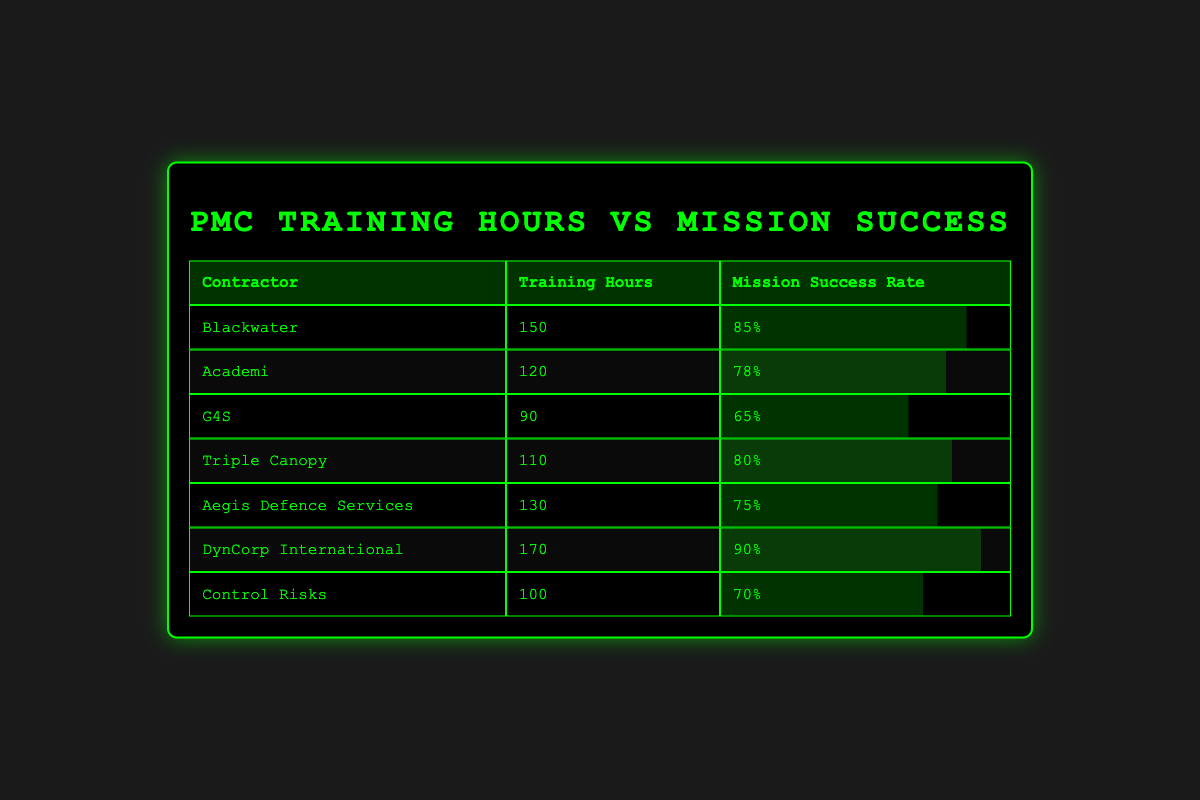What is the mission success rate for DynCorp International? From the table, I can see that the mission success rate for DynCorp International is listed in the corresponding row. It shows 90%.
Answer: 90% Which contractor has the highest number of training hours? By checking the "Training Hours" column, it is clear that DynCorp International has the highest training hours at 170.
Answer: DynCorp International What is the average mission success rate of all the contractors listed? To find the average, I add up all the mission success rates (0.85 + 0.78 + 0.65 + 0.80 + 0.75 + 0.90 + 0.70 = 5.63) and divide by the total number of contractors (7). So, 5.63 / 7 = 0.8042857, which rounds to 80.43%.
Answer: 80.43% Is the training hours for Aegis Defence Services greater than the training hours for G4S? The training hours for Aegis Defence Services is 130, while G4S has 90. Since 130 is greater than 90, the statement is true.
Answer: Yes What is the difference in mission success rate between Blackwater and Control Risks? Blackwater has a mission success rate of 0.85 and Control Risks has 0.70. To find the difference, I subtract: 0.85 - 0.70 = 0.15. Therefore, the difference is 0.15, or 15%.
Answer: 0.15 or 15% Which contractors have a mission success rate above 80%? By reviewing the "Mission Success Rate" column, I can identify that Blackwater (0.85), Triple Canopy (0.80), and DynCorp International (0.90) all have mission success rates above 80%.
Answer: Blackwater, Triple Canopy, DynCorp International What is the total of training hours for all contractors combined? To find the total, I add all training hours: 150 + 120 + 90 + 110 + 130 + 170 + 100 = 870. Therefore, the total training hours is 870.
Answer: 870 Does Academi have a higher mission success rate than G4S? Academi's mission success rate is 0.78 and G4S's is 0.65. Since 0.78 is greater than 0.65, Academi does have a higher rate.
Answer: Yes 